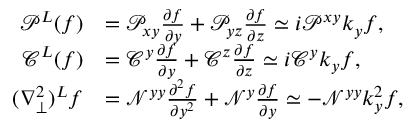<formula> <loc_0><loc_0><loc_500><loc_500>\begin{array} { r l } { \mathcal { P } ^ { L } ( f ) } & { = \mathcal { P } _ { x y } \frac { \partial f } { \partial y } + \mathcal { P } _ { y z } \frac { \partial f } { \partial z } \simeq i \mathcal { P } ^ { x y } k _ { y } f , } \\ { \mathcal { C } ^ { L } ( f ) } & { = \mathcal { C } ^ { y } \frac { \partial f } { \partial y } + \mathcal { C } ^ { z } \frac { \partial f } { \partial z } \simeq i \mathcal { C } ^ { y } k _ { y } f , } \\ { ( \nabla _ { \perp } ^ { 2 } ) ^ { L } f } & { = \mathcal { N } ^ { y y } \frac { \partial ^ { 2 } f } { \partial y ^ { 2 } } + \mathcal { N } ^ { y } \frac { \partial f } { \partial y } \simeq - \mathcal { N } ^ { y y } k _ { y } ^ { 2 } f , } \end{array}</formula> 